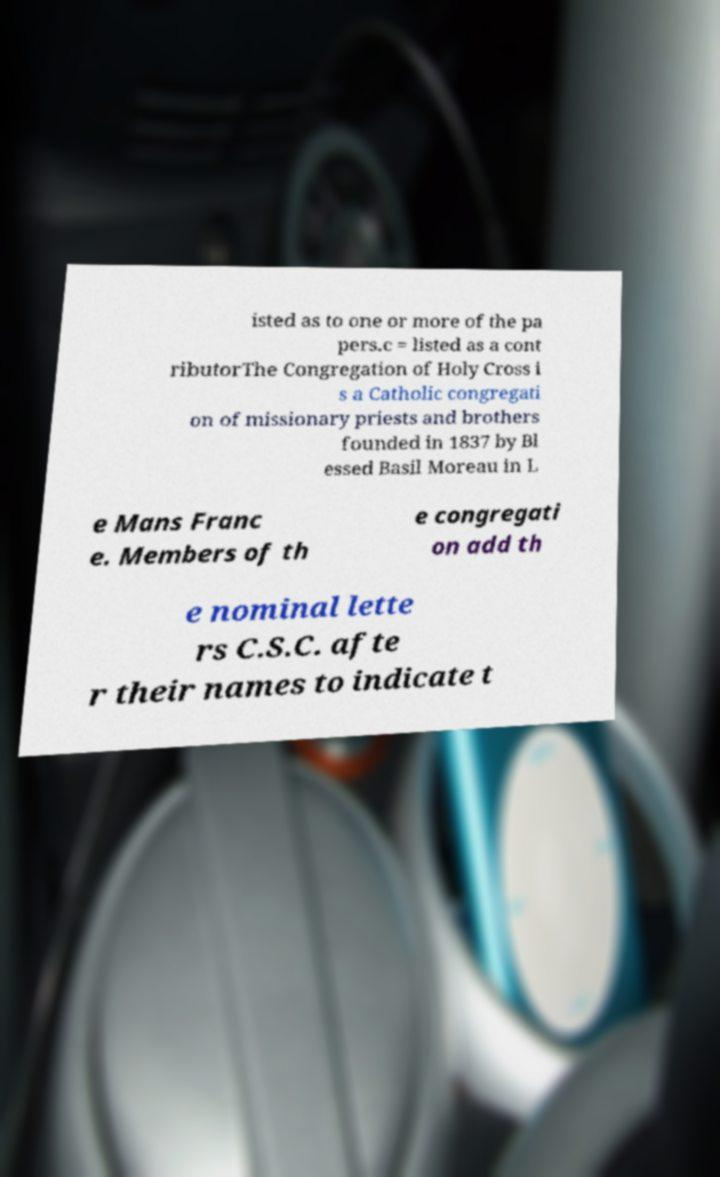Can you read and provide the text displayed in the image?This photo seems to have some interesting text. Can you extract and type it out for me? isted as to one or more of the pa pers.c = listed as a cont ributorThe Congregation of Holy Cross i s a Catholic congregati on of missionary priests and brothers founded in 1837 by Bl essed Basil Moreau in L e Mans Franc e. Members of th e congregati on add th e nominal lette rs C.S.C. afte r their names to indicate t 